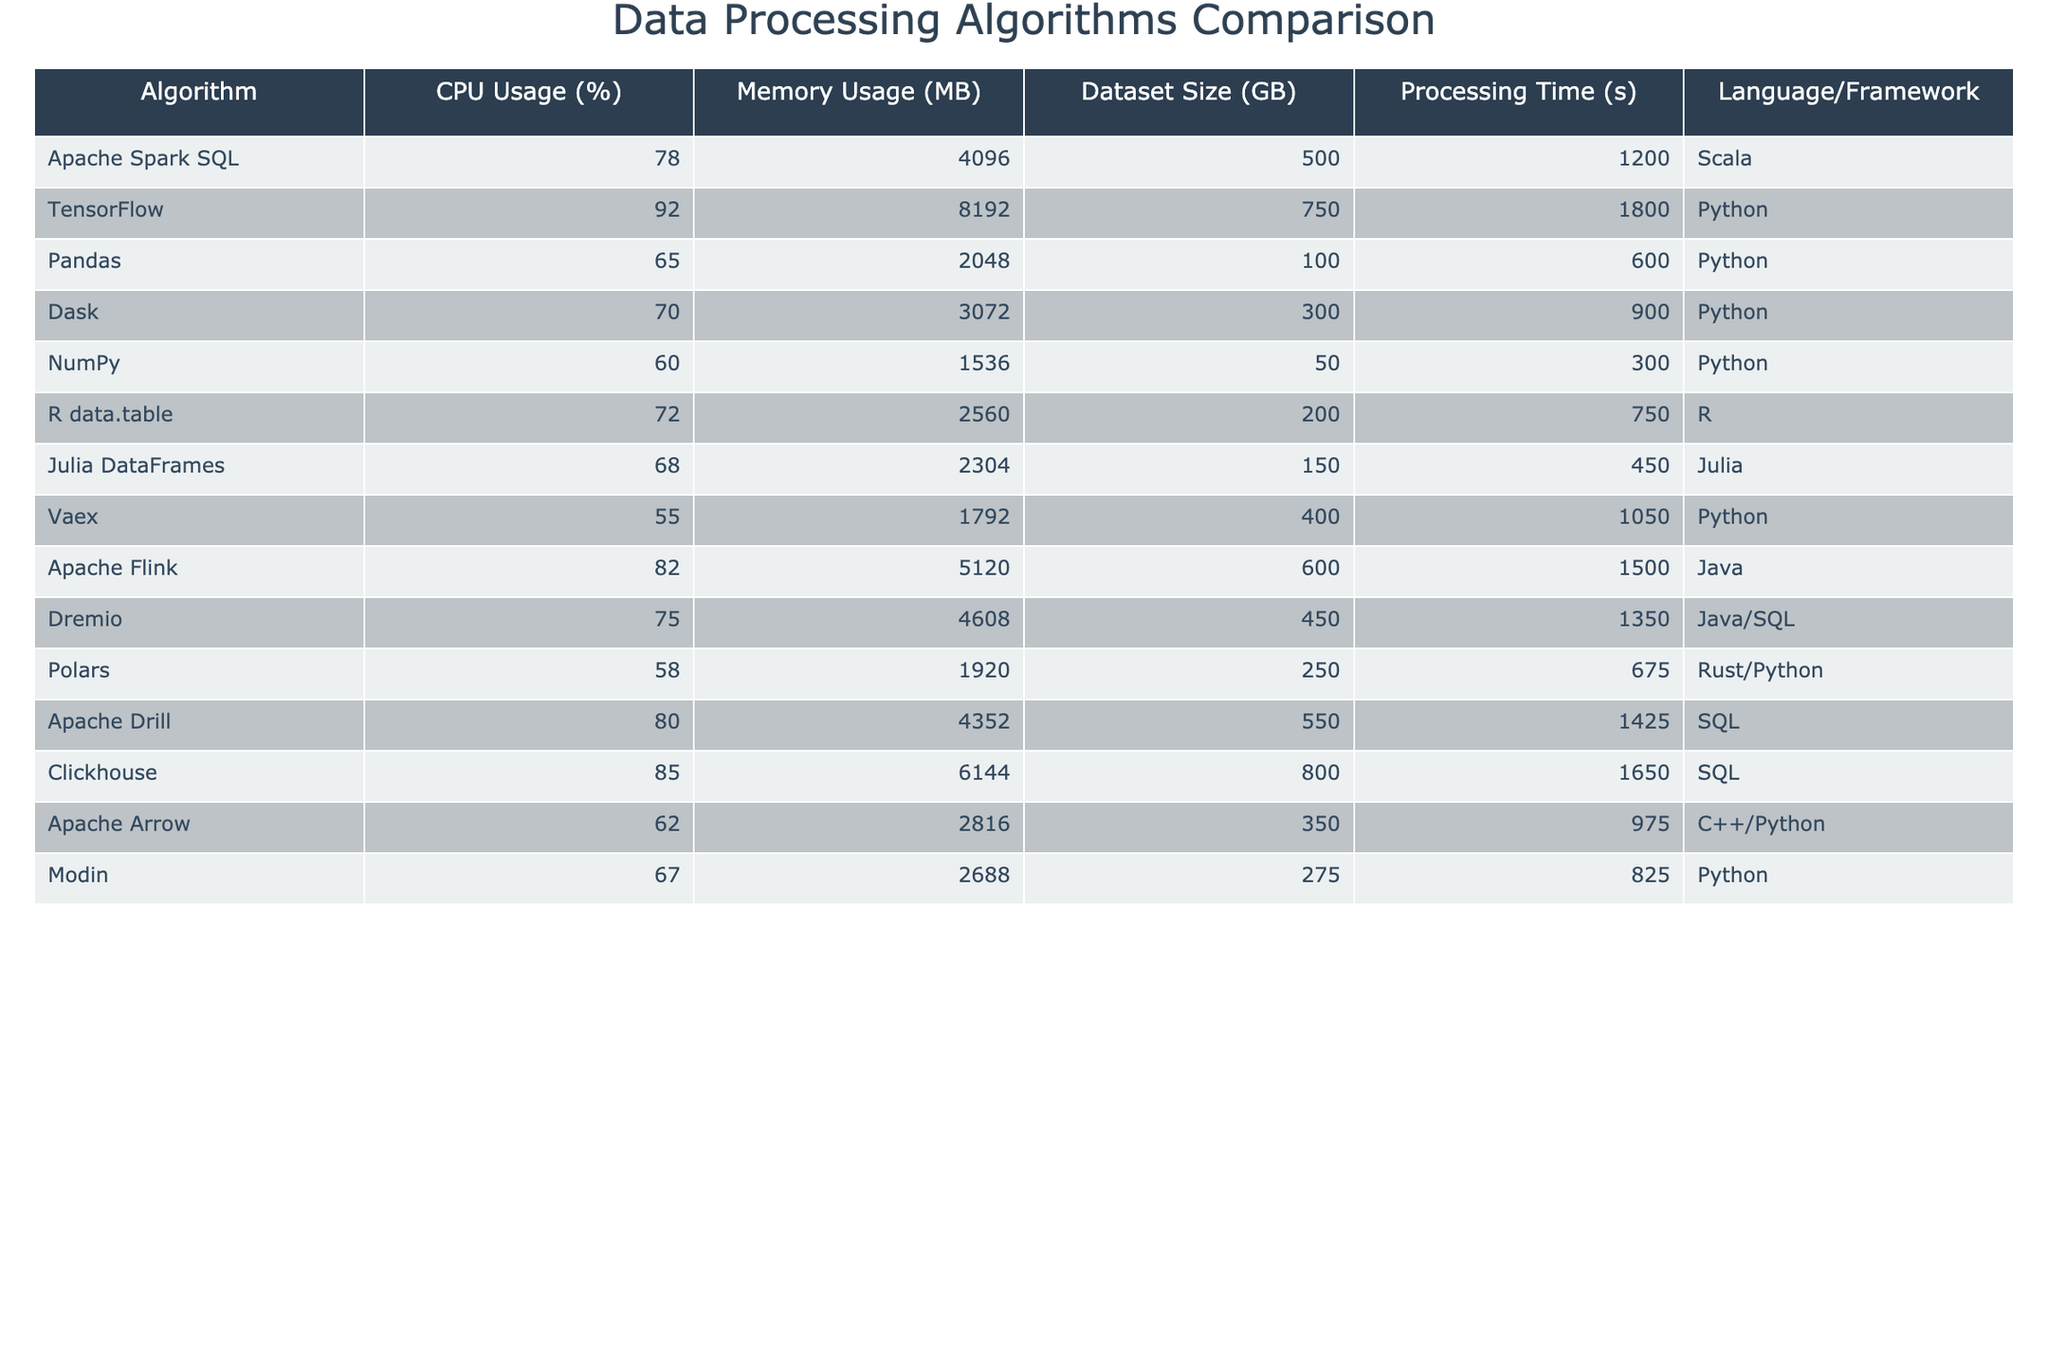What is the CPU usage of TensorFlow? The table shows that TensorFlow has a CPU usage of 92%.
Answer: 92% Which algorithm has the lowest memory usage? By looking at the memory usage column, Vaex has the lowest memory usage at 1792 MB.
Answer: 1792 MB What is the processing time of the Pandas algorithm? The table lists the processing time of the Pandas algorithm as 600 seconds.
Answer: 600 seconds Which algorithms use Python as a language/framework? The algorithms using Python include TensorFlow, Pandas, Dask, NumPy, Vaex, Apache Arrow, Modin, and Julia.
Answer: TensorFlow, Pandas, Dask, NumPy, Vaex, Apache Arrow, Modin What is the average CPU usage of all algorithms mentioned? To find the average, we sum the CPU usage values (78 + 92 + 65 + 70 + 60 + 72 + 68 + 55 + 82 + 75 + 58 + 80 + 85 + 62 + 67) = 1080 and divide by the number of algorithms (15), which gives us an average CPU usage of 72%.
Answer: 72% Is the memory usage of Apache Flink higher than that of Dremio? The memory usage of Apache Flink is 5120 MB and for Dremio, it is 4608 MB. Since 5120 MB is greater than 4608 MB, the statement is true.
Answer: Yes Which algorithm has the longest processing time and how long is it? Clickhouse has the longest processing time at 1650 seconds as per the table.
Answer: Clickhouse, 1650 seconds What is the difference in processing time between Dask and NumPy? The processing time for Dask is 900 seconds and for NumPy it is 300 seconds. The difference is 900 - 300 = 600 seconds.
Answer: 600 seconds How many algorithms have a CPU usage greater than 80%? The algorithms with CPU usage greater than 80% are TensorFlow (92%), Apache Flink (82%), and Clickhouse (85%), totaling three algorithms.
Answer: 3 What is the combined memory usage of all algorithms using R? The algorithms using R are R data.table and Polars, which have memory usages of 2560 MB and 1920 MB respectively. Their combined memory usage is 2560 + 1920 = 4480 MB.
Answer: 4480 MB Is the dataset size for Julia DataFrames greater than that for NumPy? The dataset size for Julia DataFrames is 150 GB, while for NumPy it is 50 GB. Since 150 GB is greater than 50 GB, this statement is true.
Answer: Yes 